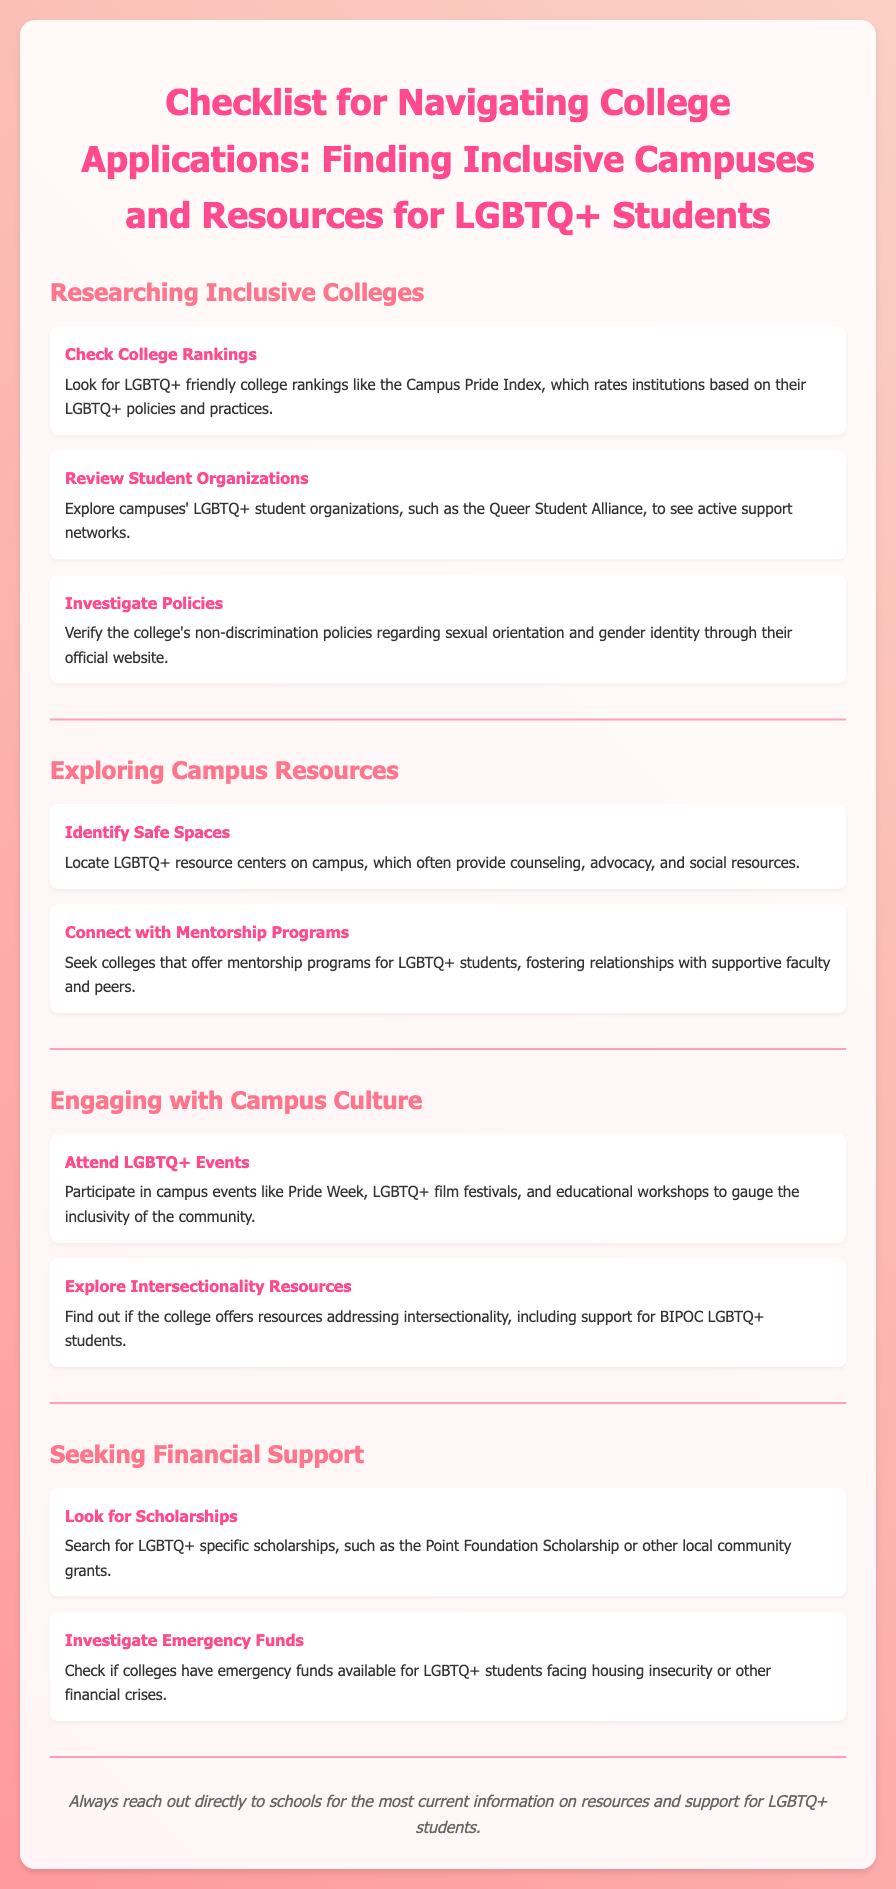What is the title of the document? The title of the document is specified in the header section of the HTML code.
Answer: Checklist for Navigating College Applications: Finding Inclusive Campuses and Resources for LGBTQ+ Students What is one resource recommended for researching inclusive colleges? The document lists specific tips under the "Researching Inclusive Colleges" section.
Answer: Campus Pride Index Name one type of event to attend for gauging campus culture. The document suggests various activities under the "Engaging with Campus Culture" section.
Answer: Pride Week What type of support can LGBTQ+ resource centers provide? Resource centers typically offer a variety of assistance, as stated in the "Exploring Campus Resources" section.
Answer: Counseling What is a scholarship mentioned in the document? The document includes examples of scholarships in the "Seeking Financial Support" section.
Answer: Point Foundation Scholarship How many sections are there in the document? The document is divided into several distinct areas, which can be counted directly.
Answer: Four What should students do to get the latest information on LGBTQ+ resources? The note at the end of the document provides guidance on obtaining accurate information.
Answer: Reach out directly to schools What does the document suggest investigating about colleges? The document advises checking specific aspects concerning college policies and resources.
Answer: Non-discrimination policies 